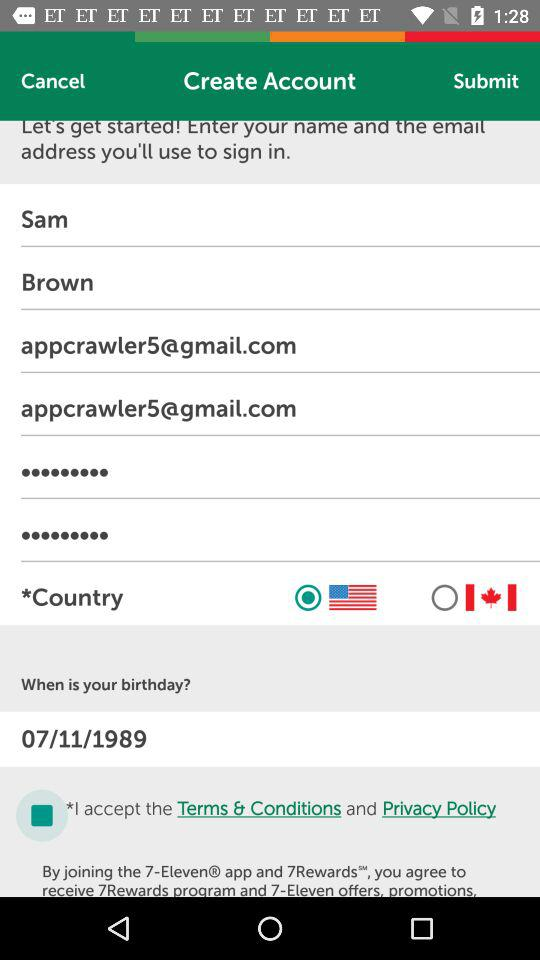What is the email address entered in the second text input?
Answer the question using a single word or phrase. Appcrawler5@gmail.com 